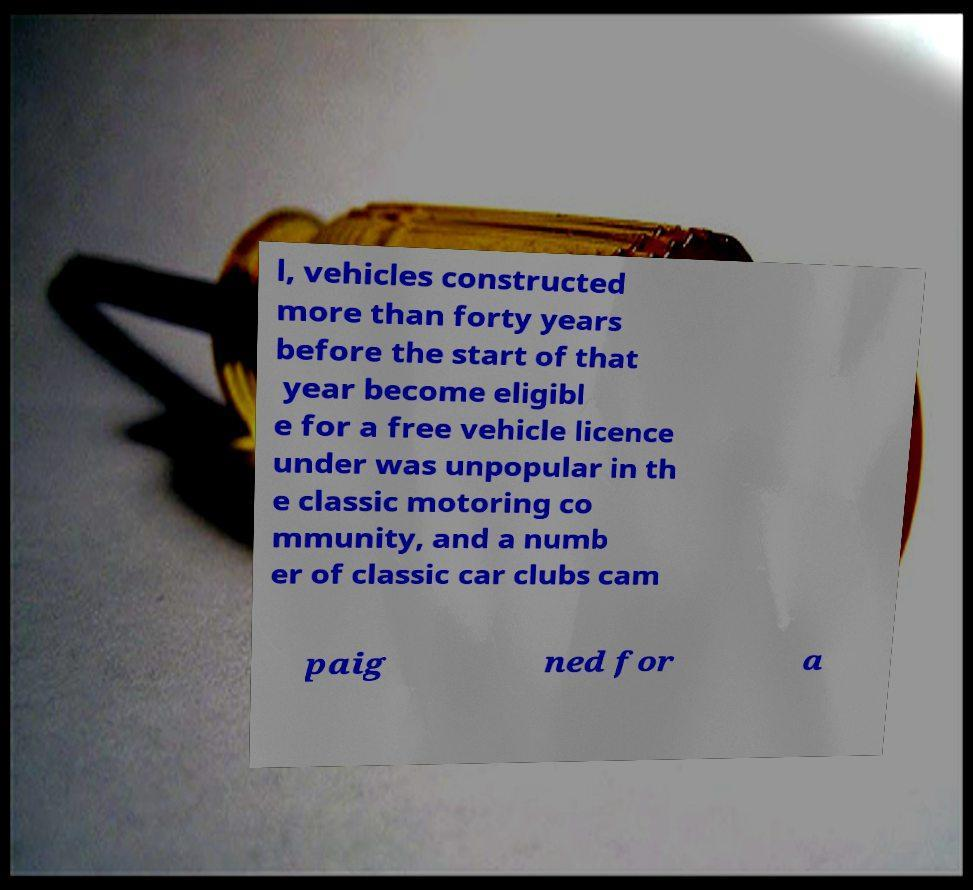There's text embedded in this image that I need extracted. Can you transcribe it verbatim? l, vehicles constructed more than forty years before the start of that year become eligibl e for a free vehicle licence under was unpopular in th e classic motoring co mmunity, and a numb er of classic car clubs cam paig ned for a 